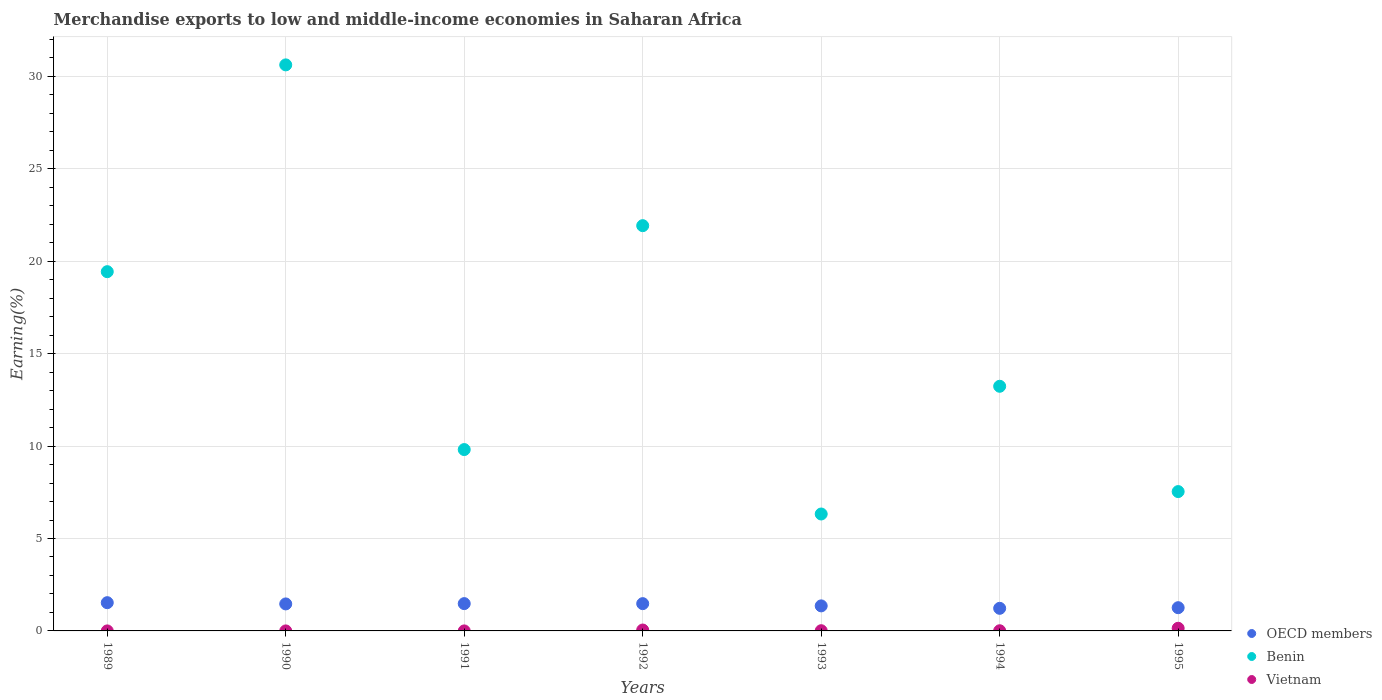How many different coloured dotlines are there?
Your answer should be compact. 3. What is the percentage of amount earned from merchandise exports in Benin in 1991?
Your response must be concise. 9.81. Across all years, what is the maximum percentage of amount earned from merchandise exports in OECD members?
Give a very brief answer. 1.53. Across all years, what is the minimum percentage of amount earned from merchandise exports in Vietnam?
Offer a very short reply. 0. What is the total percentage of amount earned from merchandise exports in OECD members in the graph?
Ensure brevity in your answer.  9.78. What is the difference between the percentage of amount earned from merchandise exports in Vietnam in 1989 and that in 1991?
Your answer should be very brief. 0. What is the difference between the percentage of amount earned from merchandise exports in Benin in 1993 and the percentage of amount earned from merchandise exports in OECD members in 1990?
Keep it short and to the point. 4.86. What is the average percentage of amount earned from merchandise exports in Benin per year?
Give a very brief answer. 15.56. In the year 1992, what is the difference between the percentage of amount earned from merchandise exports in Vietnam and percentage of amount earned from merchandise exports in OECD members?
Your response must be concise. -1.43. In how many years, is the percentage of amount earned from merchandise exports in Benin greater than 3 %?
Your answer should be compact. 7. What is the ratio of the percentage of amount earned from merchandise exports in Benin in 1991 to that in 1995?
Make the answer very short. 1.3. What is the difference between the highest and the second highest percentage of amount earned from merchandise exports in OECD members?
Provide a succinct answer. 0.05. What is the difference between the highest and the lowest percentage of amount earned from merchandise exports in Vietnam?
Make the answer very short. 0.14. Does the percentage of amount earned from merchandise exports in OECD members monotonically increase over the years?
Keep it short and to the point. No. Is the percentage of amount earned from merchandise exports in Benin strictly greater than the percentage of amount earned from merchandise exports in OECD members over the years?
Provide a succinct answer. Yes. Is the percentage of amount earned from merchandise exports in OECD members strictly less than the percentage of amount earned from merchandise exports in Vietnam over the years?
Offer a very short reply. No. How many years are there in the graph?
Provide a short and direct response. 7. What is the difference between two consecutive major ticks on the Y-axis?
Make the answer very short. 5. Where does the legend appear in the graph?
Offer a terse response. Bottom right. How many legend labels are there?
Ensure brevity in your answer.  3. What is the title of the graph?
Give a very brief answer. Merchandise exports to low and middle-income economies in Saharan Africa. What is the label or title of the X-axis?
Make the answer very short. Years. What is the label or title of the Y-axis?
Give a very brief answer. Earning(%). What is the Earning(%) in OECD members in 1989?
Make the answer very short. 1.53. What is the Earning(%) in Benin in 1989?
Ensure brevity in your answer.  19.44. What is the Earning(%) of Vietnam in 1989?
Ensure brevity in your answer.  0. What is the Earning(%) in OECD members in 1990?
Your answer should be very brief. 1.46. What is the Earning(%) in Benin in 1990?
Give a very brief answer. 30.62. What is the Earning(%) in Vietnam in 1990?
Offer a terse response. 0. What is the Earning(%) of OECD members in 1991?
Your response must be concise. 1.48. What is the Earning(%) in Benin in 1991?
Provide a succinct answer. 9.81. What is the Earning(%) in Vietnam in 1991?
Provide a succinct answer. 0. What is the Earning(%) of OECD members in 1992?
Offer a very short reply. 1.48. What is the Earning(%) in Benin in 1992?
Give a very brief answer. 21.92. What is the Earning(%) in Vietnam in 1992?
Your answer should be compact. 0.05. What is the Earning(%) in OECD members in 1993?
Provide a succinct answer. 1.35. What is the Earning(%) of Benin in 1993?
Offer a terse response. 6.33. What is the Earning(%) in Vietnam in 1993?
Provide a succinct answer. 0.01. What is the Earning(%) in OECD members in 1994?
Your answer should be compact. 1.22. What is the Earning(%) of Benin in 1994?
Provide a short and direct response. 13.24. What is the Earning(%) of Vietnam in 1994?
Provide a short and direct response. 0.01. What is the Earning(%) of OECD members in 1995?
Give a very brief answer. 1.26. What is the Earning(%) in Benin in 1995?
Your response must be concise. 7.54. What is the Earning(%) of Vietnam in 1995?
Ensure brevity in your answer.  0.14. Across all years, what is the maximum Earning(%) in OECD members?
Provide a short and direct response. 1.53. Across all years, what is the maximum Earning(%) of Benin?
Provide a short and direct response. 30.62. Across all years, what is the maximum Earning(%) in Vietnam?
Offer a terse response. 0.14. Across all years, what is the minimum Earning(%) of OECD members?
Ensure brevity in your answer.  1.22. Across all years, what is the minimum Earning(%) of Benin?
Your answer should be very brief. 6.33. Across all years, what is the minimum Earning(%) in Vietnam?
Ensure brevity in your answer.  0. What is the total Earning(%) of OECD members in the graph?
Provide a succinct answer. 9.78. What is the total Earning(%) in Benin in the graph?
Provide a short and direct response. 108.89. What is the total Earning(%) in Vietnam in the graph?
Give a very brief answer. 0.21. What is the difference between the Earning(%) of OECD members in 1989 and that in 1990?
Ensure brevity in your answer.  0.07. What is the difference between the Earning(%) in Benin in 1989 and that in 1990?
Offer a very short reply. -11.19. What is the difference between the Earning(%) of Vietnam in 1989 and that in 1990?
Provide a short and direct response. -0. What is the difference between the Earning(%) in OECD members in 1989 and that in 1991?
Keep it short and to the point. 0.05. What is the difference between the Earning(%) of Benin in 1989 and that in 1991?
Keep it short and to the point. 9.62. What is the difference between the Earning(%) in Vietnam in 1989 and that in 1991?
Your answer should be very brief. 0. What is the difference between the Earning(%) of OECD members in 1989 and that in 1992?
Offer a terse response. 0.05. What is the difference between the Earning(%) of Benin in 1989 and that in 1992?
Provide a short and direct response. -2.49. What is the difference between the Earning(%) in Vietnam in 1989 and that in 1992?
Offer a very short reply. -0.05. What is the difference between the Earning(%) in OECD members in 1989 and that in 1993?
Make the answer very short. 0.17. What is the difference between the Earning(%) of Benin in 1989 and that in 1993?
Ensure brevity in your answer.  13.11. What is the difference between the Earning(%) in Vietnam in 1989 and that in 1993?
Provide a short and direct response. -0.01. What is the difference between the Earning(%) of OECD members in 1989 and that in 1994?
Offer a very short reply. 0.31. What is the difference between the Earning(%) in Benin in 1989 and that in 1994?
Ensure brevity in your answer.  6.2. What is the difference between the Earning(%) of Vietnam in 1989 and that in 1994?
Your answer should be compact. -0.01. What is the difference between the Earning(%) in OECD members in 1989 and that in 1995?
Offer a terse response. 0.27. What is the difference between the Earning(%) of Benin in 1989 and that in 1995?
Offer a terse response. 11.9. What is the difference between the Earning(%) of Vietnam in 1989 and that in 1995?
Ensure brevity in your answer.  -0.14. What is the difference between the Earning(%) of OECD members in 1990 and that in 1991?
Provide a short and direct response. -0.02. What is the difference between the Earning(%) in Benin in 1990 and that in 1991?
Provide a short and direct response. 20.81. What is the difference between the Earning(%) of OECD members in 1990 and that in 1992?
Provide a succinct answer. -0.01. What is the difference between the Earning(%) of Benin in 1990 and that in 1992?
Make the answer very short. 8.7. What is the difference between the Earning(%) of Vietnam in 1990 and that in 1992?
Your answer should be compact. -0.05. What is the difference between the Earning(%) of OECD members in 1990 and that in 1993?
Provide a short and direct response. 0.11. What is the difference between the Earning(%) in Benin in 1990 and that in 1993?
Your answer should be very brief. 24.3. What is the difference between the Earning(%) in Vietnam in 1990 and that in 1993?
Give a very brief answer. -0.01. What is the difference between the Earning(%) of OECD members in 1990 and that in 1994?
Your answer should be very brief. 0.24. What is the difference between the Earning(%) of Benin in 1990 and that in 1994?
Give a very brief answer. 17.39. What is the difference between the Earning(%) in Vietnam in 1990 and that in 1994?
Give a very brief answer. -0.01. What is the difference between the Earning(%) of OECD members in 1990 and that in 1995?
Ensure brevity in your answer.  0.2. What is the difference between the Earning(%) of Benin in 1990 and that in 1995?
Offer a terse response. 23.08. What is the difference between the Earning(%) in Vietnam in 1990 and that in 1995?
Keep it short and to the point. -0.14. What is the difference between the Earning(%) in OECD members in 1991 and that in 1992?
Keep it short and to the point. 0. What is the difference between the Earning(%) in Benin in 1991 and that in 1992?
Your response must be concise. -12.11. What is the difference between the Earning(%) of Vietnam in 1991 and that in 1992?
Your response must be concise. -0.05. What is the difference between the Earning(%) of OECD members in 1991 and that in 1993?
Offer a very short reply. 0.12. What is the difference between the Earning(%) of Benin in 1991 and that in 1993?
Give a very brief answer. 3.49. What is the difference between the Earning(%) of Vietnam in 1991 and that in 1993?
Offer a very short reply. -0.01. What is the difference between the Earning(%) in OECD members in 1991 and that in 1994?
Make the answer very short. 0.25. What is the difference between the Earning(%) of Benin in 1991 and that in 1994?
Give a very brief answer. -3.42. What is the difference between the Earning(%) in Vietnam in 1991 and that in 1994?
Make the answer very short. -0.01. What is the difference between the Earning(%) of OECD members in 1991 and that in 1995?
Provide a succinct answer. 0.22. What is the difference between the Earning(%) of Benin in 1991 and that in 1995?
Ensure brevity in your answer.  2.27. What is the difference between the Earning(%) of Vietnam in 1991 and that in 1995?
Ensure brevity in your answer.  -0.14. What is the difference between the Earning(%) of OECD members in 1992 and that in 1993?
Your response must be concise. 0.12. What is the difference between the Earning(%) in Benin in 1992 and that in 1993?
Give a very brief answer. 15.6. What is the difference between the Earning(%) in Vietnam in 1992 and that in 1993?
Offer a very short reply. 0.04. What is the difference between the Earning(%) in OECD members in 1992 and that in 1994?
Your response must be concise. 0.25. What is the difference between the Earning(%) of Benin in 1992 and that in 1994?
Make the answer very short. 8.69. What is the difference between the Earning(%) of Vietnam in 1992 and that in 1994?
Your answer should be compact. 0.04. What is the difference between the Earning(%) of OECD members in 1992 and that in 1995?
Offer a very short reply. 0.22. What is the difference between the Earning(%) of Benin in 1992 and that in 1995?
Ensure brevity in your answer.  14.39. What is the difference between the Earning(%) of Vietnam in 1992 and that in 1995?
Provide a short and direct response. -0.09. What is the difference between the Earning(%) in OECD members in 1993 and that in 1994?
Your answer should be compact. 0.13. What is the difference between the Earning(%) in Benin in 1993 and that in 1994?
Give a very brief answer. -6.91. What is the difference between the Earning(%) in Vietnam in 1993 and that in 1994?
Give a very brief answer. 0. What is the difference between the Earning(%) in OECD members in 1993 and that in 1995?
Ensure brevity in your answer.  0.1. What is the difference between the Earning(%) of Benin in 1993 and that in 1995?
Your response must be concise. -1.21. What is the difference between the Earning(%) in Vietnam in 1993 and that in 1995?
Give a very brief answer. -0.13. What is the difference between the Earning(%) in OECD members in 1994 and that in 1995?
Keep it short and to the point. -0.03. What is the difference between the Earning(%) of Benin in 1994 and that in 1995?
Your answer should be very brief. 5.7. What is the difference between the Earning(%) of Vietnam in 1994 and that in 1995?
Your answer should be very brief. -0.13. What is the difference between the Earning(%) in OECD members in 1989 and the Earning(%) in Benin in 1990?
Offer a very short reply. -29.09. What is the difference between the Earning(%) of OECD members in 1989 and the Earning(%) of Vietnam in 1990?
Your answer should be compact. 1.53. What is the difference between the Earning(%) in Benin in 1989 and the Earning(%) in Vietnam in 1990?
Make the answer very short. 19.43. What is the difference between the Earning(%) of OECD members in 1989 and the Earning(%) of Benin in 1991?
Provide a succinct answer. -8.28. What is the difference between the Earning(%) of OECD members in 1989 and the Earning(%) of Vietnam in 1991?
Ensure brevity in your answer.  1.53. What is the difference between the Earning(%) in Benin in 1989 and the Earning(%) in Vietnam in 1991?
Your answer should be compact. 19.43. What is the difference between the Earning(%) in OECD members in 1989 and the Earning(%) in Benin in 1992?
Provide a succinct answer. -20.4. What is the difference between the Earning(%) of OECD members in 1989 and the Earning(%) of Vietnam in 1992?
Keep it short and to the point. 1.48. What is the difference between the Earning(%) in Benin in 1989 and the Earning(%) in Vietnam in 1992?
Your response must be concise. 19.39. What is the difference between the Earning(%) of OECD members in 1989 and the Earning(%) of Benin in 1993?
Offer a terse response. -4.8. What is the difference between the Earning(%) in OECD members in 1989 and the Earning(%) in Vietnam in 1993?
Your response must be concise. 1.52. What is the difference between the Earning(%) in Benin in 1989 and the Earning(%) in Vietnam in 1993?
Give a very brief answer. 19.42. What is the difference between the Earning(%) of OECD members in 1989 and the Earning(%) of Benin in 1994?
Provide a short and direct response. -11.71. What is the difference between the Earning(%) in OECD members in 1989 and the Earning(%) in Vietnam in 1994?
Provide a succinct answer. 1.52. What is the difference between the Earning(%) of Benin in 1989 and the Earning(%) of Vietnam in 1994?
Your response must be concise. 19.43. What is the difference between the Earning(%) of OECD members in 1989 and the Earning(%) of Benin in 1995?
Keep it short and to the point. -6.01. What is the difference between the Earning(%) of OECD members in 1989 and the Earning(%) of Vietnam in 1995?
Provide a short and direct response. 1.38. What is the difference between the Earning(%) of Benin in 1989 and the Earning(%) of Vietnam in 1995?
Make the answer very short. 19.29. What is the difference between the Earning(%) of OECD members in 1990 and the Earning(%) of Benin in 1991?
Your answer should be very brief. -8.35. What is the difference between the Earning(%) of OECD members in 1990 and the Earning(%) of Vietnam in 1991?
Make the answer very short. 1.46. What is the difference between the Earning(%) in Benin in 1990 and the Earning(%) in Vietnam in 1991?
Your answer should be compact. 30.62. What is the difference between the Earning(%) in OECD members in 1990 and the Earning(%) in Benin in 1992?
Make the answer very short. -20.46. What is the difference between the Earning(%) of OECD members in 1990 and the Earning(%) of Vietnam in 1992?
Provide a short and direct response. 1.41. What is the difference between the Earning(%) of Benin in 1990 and the Earning(%) of Vietnam in 1992?
Provide a succinct answer. 30.57. What is the difference between the Earning(%) in OECD members in 1990 and the Earning(%) in Benin in 1993?
Give a very brief answer. -4.86. What is the difference between the Earning(%) of OECD members in 1990 and the Earning(%) of Vietnam in 1993?
Provide a succinct answer. 1.45. What is the difference between the Earning(%) in Benin in 1990 and the Earning(%) in Vietnam in 1993?
Offer a terse response. 30.61. What is the difference between the Earning(%) in OECD members in 1990 and the Earning(%) in Benin in 1994?
Give a very brief answer. -11.77. What is the difference between the Earning(%) in OECD members in 1990 and the Earning(%) in Vietnam in 1994?
Keep it short and to the point. 1.45. What is the difference between the Earning(%) in Benin in 1990 and the Earning(%) in Vietnam in 1994?
Give a very brief answer. 30.61. What is the difference between the Earning(%) of OECD members in 1990 and the Earning(%) of Benin in 1995?
Your answer should be compact. -6.08. What is the difference between the Earning(%) of OECD members in 1990 and the Earning(%) of Vietnam in 1995?
Make the answer very short. 1.32. What is the difference between the Earning(%) in Benin in 1990 and the Earning(%) in Vietnam in 1995?
Make the answer very short. 30.48. What is the difference between the Earning(%) in OECD members in 1991 and the Earning(%) in Benin in 1992?
Make the answer very short. -20.45. What is the difference between the Earning(%) in OECD members in 1991 and the Earning(%) in Vietnam in 1992?
Your answer should be very brief. 1.43. What is the difference between the Earning(%) of Benin in 1991 and the Earning(%) of Vietnam in 1992?
Make the answer very short. 9.76. What is the difference between the Earning(%) of OECD members in 1991 and the Earning(%) of Benin in 1993?
Give a very brief answer. -4.85. What is the difference between the Earning(%) of OECD members in 1991 and the Earning(%) of Vietnam in 1993?
Make the answer very short. 1.47. What is the difference between the Earning(%) of Benin in 1991 and the Earning(%) of Vietnam in 1993?
Your response must be concise. 9.8. What is the difference between the Earning(%) of OECD members in 1991 and the Earning(%) of Benin in 1994?
Give a very brief answer. -11.76. What is the difference between the Earning(%) of OECD members in 1991 and the Earning(%) of Vietnam in 1994?
Your answer should be compact. 1.47. What is the difference between the Earning(%) of Benin in 1991 and the Earning(%) of Vietnam in 1994?
Your answer should be compact. 9.8. What is the difference between the Earning(%) of OECD members in 1991 and the Earning(%) of Benin in 1995?
Your answer should be compact. -6.06. What is the difference between the Earning(%) of OECD members in 1991 and the Earning(%) of Vietnam in 1995?
Make the answer very short. 1.33. What is the difference between the Earning(%) in Benin in 1991 and the Earning(%) in Vietnam in 1995?
Offer a terse response. 9.67. What is the difference between the Earning(%) of OECD members in 1992 and the Earning(%) of Benin in 1993?
Keep it short and to the point. -4.85. What is the difference between the Earning(%) in OECD members in 1992 and the Earning(%) in Vietnam in 1993?
Keep it short and to the point. 1.46. What is the difference between the Earning(%) in Benin in 1992 and the Earning(%) in Vietnam in 1993?
Your response must be concise. 21.91. What is the difference between the Earning(%) of OECD members in 1992 and the Earning(%) of Benin in 1994?
Keep it short and to the point. -11.76. What is the difference between the Earning(%) of OECD members in 1992 and the Earning(%) of Vietnam in 1994?
Provide a succinct answer. 1.47. What is the difference between the Earning(%) in Benin in 1992 and the Earning(%) in Vietnam in 1994?
Keep it short and to the point. 21.92. What is the difference between the Earning(%) of OECD members in 1992 and the Earning(%) of Benin in 1995?
Your answer should be compact. -6.06. What is the difference between the Earning(%) of OECD members in 1992 and the Earning(%) of Vietnam in 1995?
Give a very brief answer. 1.33. What is the difference between the Earning(%) in Benin in 1992 and the Earning(%) in Vietnam in 1995?
Give a very brief answer. 21.78. What is the difference between the Earning(%) of OECD members in 1993 and the Earning(%) of Benin in 1994?
Give a very brief answer. -11.88. What is the difference between the Earning(%) in OECD members in 1993 and the Earning(%) in Vietnam in 1994?
Give a very brief answer. 1.35. What is the difference between the Earning(%) of Benin in 1993 and the Earning(%) of Vietnam in 1994?
Offer a terse response. 6.32. What is the difference between the Earning(%) of OECD members in 1993 and the Earning(%) of Benin in 1995?
Your response must be concise. -6.18. What is the difference between the Earning(%) of OECD members in 1993 and the Earning(%) of Vietnam in 1995?
Your answer should be compact. 1.21. What is the difference between the Earning(%) in Benin in 1993 and the Earning(%) in Vietnam in 1995?
Provide a short and direct response. 6.18. What is the difference between the Earning(%) in OECD members in 1994 and the Earning(%) in Benin in 1995?
Offer a very short reply. -6.32. What is the difference between the Earning(%) in OECD members in 1994 and the Earning(%) in Vietnam in 1995?
Your answer should be very brief. 1.08. What is the difference between the Earning(%) of Benin in 1994 and the Earning(%) of Vietnam in 1995?
Offer a very short reply. 13.09. What is the average Earning(%) in OECD members per year?
Ensure brevity in your answer.  1.4. What is the average Earning(%) in Benin per year?
Your response must be concise. 15.56. What is the average Earning(%) of Vietnam per year?
Provide a short and direct response. 0.03. In the year 1989, what is the difference between the Earning(%) in OECD members and Earning(%) in Benin?
Give a very brief answer. -17.91. In the year 1989, what is the difference between the Earning(%) of OECD members and Earning(%) of Vietnam?
Offer a very short reply. 1.53. In the year 1989, what is the difference between the Earning(%) in Benin and Earning(%) in Vietnam?
Offer a very short reply. 19.43. In the year 1990, what is the difference between the Earning(%) of OECD members and Earning(%) of Benin?
Offer a very short reply. -29.16. In the year 1990, what is the difference between the Earning(%) of OECD members and Earning(%) of Vietnam?
Keep it short and to the point. 1.46. In the year 1990, what is the difference between the Earning(%) in Benin and Earning(%) in Vietnam?
Provide a short and direct response. 30.62. In the year 1991, what is the difference between the Earning(%) in OECD members and Earning(%) in Benin?
Your response must be concise. -8.33. In the year 1991, what is the difference between the Earning(%) in OECD members and Earning(%) in Vietnam?
Offer a terse response. 1.48. In the year 1991, what is the difference between the Earning(%) in Benin and Earning(%) in Vietnam?
Your answer should be compact. 9.81. In the year 1992, what is the difference between the Earning(%) in OECD members and Earning(%) in Benin?
Give a very brief answer. -20.45. In the year 1992, what is the difference between the Earning(%) of OECD members and Earning(%) of Vietnam?
Your answer should be very brief. 1.43. In the year 1992, what is the difference between the Earning(%) in Benin and Earning(%) in Vietnam?
Make the answer very short. 21.88. In the year 1993, what is the difference between the Earning(%) of OECD members and Earning(%) of Benin?
Your answer should be very brief. -4.97. In the year 1993, what is the difference between the Earning(%) of OECD members and Earning(%) of Vietnam?
Give a very brief answer. 1.34. In the year 1993, what is the difference between the Earning(%) of Benin and Earning(%) of Vietnam?
Keep it short and to the point. 6.31. In the year 1994, what is the difference between the Earning(%) in OECD members and Earning(%) in Benin?
Offer a very short reply. -12.01. In the year 1994, what is the difference between the Earning(%) of OECD members and Earning(%) of Vietnam?
Keep it short and to the point. 1.21. In the year 1994, what is the difference between the Earning(%) in Benin and Earning(%) in Vietnam?
Your response must be concise. 13.23. In the year 1995, what is the difference between the Earning(%) in OECD members and Earning(%) in Benin?
Provide a short and direct response. -6.28. In the year 1995, what is the difference between the Earning(%) of OECD members and Earning(%) of Vietnam?
Ensure brevity in your answer.  1.11. In the year 1995, what is the difference between the Earning(%) of Benin and Earning(%) of Vietnam?
Offer a very short reply. 7.39. What is the ratio of the Earning(%) of OECD members in 1989 to that in 1990?
Offer a terse response. 1.05. What is the ratio of the Earning(%) in Benin in 1989 to that in 1990?
Offer a very short reply. 0.63. What is the ratio of the Earning(%) of Vietnam in 1989 to that in 1990?
Provide a succinct answer. 0.72. What is the ratio of the Earning(%) of OECD members in 1989 to that in 1991?
Provide a short and direct response. 1.03. What is the ratio of the Earning(%) in Benin in 1989 to that in 1991?
Provide a succinct answer. 1.98. What is the ratio of the Earning(%) in Vietnam in 1989 to that in 1991?
Your answer should be compact. 1.77. What is the ratio of the Earning(%) of OECD members in 1989 to that in 1992?
Your response must be concise. 1.04. What is the ratio of the Earning(%) of Benin in 1989 to that in 1992?
Make the answer very short. 0.89. What is the ratio of the Earning(%) of OECD members in 1989 to that in 1993?
Give a very brief answer. 1.13. What is the ratio of the Earning(%) in Benin in 1989 to that in 1993?
Offer a terse response. 3.07. What is the ratio of the Earning(%) in Vietnam in 1989 to that in 1993?
Provide a succinct answer. 0.04. What is the ratio of the Earning(%) of OECD members in 1989 to that in 1994?
Keep it short and to the point. 1.25. What is the ratio of the Earning(%) of Benin in 1989 to that in 1994?
Offer a terse response. 1.47. What is the ratio of the Earning(%) in Vietnam in 1989 to that in 1994?
Make the answer very short. 0.05. What is the ratio of the Earning(%) of OECD members in 1989 to that in 1995?
Ensure brevity in your answer.  1.22. What is the ratio of the Earning(%) in Benin in 1989 to that in 1995?
Give a very brief answer. 2.58. What is the ratio of the Earning(%) in Vietnam in 1989 to that in 1995?
Provide a short and direct response. 0. What is the ratio of the Earning(%) of OECD members in 1990 to that in 1991?
Offer a terse response. 0.99. What is the ratio of the Earning(%) in Benin in 1990 to that in 1991?
Provide a succinct answer. 3.12. What is the ratio of the Earning(%) in Vietnam in 1990 to that in 1991?
Offer a terse response. 2.46. What is the ratio of the Earning(%) of OECD members in 1990 to that in 1992?
Offer a very short reply. 0.99. What is the ratio of the Earning(%) in Benin in 1990 to that in 1992?
Your answer should be compact. 1.4. What is the ratio of the Earning(%) in Vietnam in 1990 to that in 1992?
Provide a short and direct response. 0.01. What is the ratio of the Earning(%) of OECD members in 1990 to that in 1993?
Provide a succinct answer. 1.08. What is the ratio of the Earning(%) in Benin in 1990 to that in 1993?
Your response must be concise. 4.84. What is the ratio of the Earning(%) of Vietnam in 1990 to that in 1993?
Your answer should be compact. 0.06. What is the ratio of the Earning(%) of OECD members in 1990 to that in 1994?
Your response must be concise. 1.19. What is the ratio of the Earning(%) of Benin in 1990 to that in 1994?
Keep it short and to the point. 2.31. What is the ratio of the Earning(%) of Vietnam in 1990 to that in 1994?
Your response must be concise. 0.07. What is the ratio of the Earning(%) of OECD members in 1990 to that in 1995?
Offer a very short reply. 1.16. What is the ratio of the Earning(%) in Benin in 1990 to that in 1995?
Provide a succinct answer. 4.06. What is the ratio of the Earning(%) of Vietnam in 1990 to that in 1995?
Offer a terse response. 0. What is the ratio of the Earning(%) in OECD members in 1991 to that in 1992?
Provide a succinct answer. 1. What is the ratio of the Earning(%) of Benin in 1991 to that in 1992?
Your answer should be very brief. 0.45. What is the ratio of the Earning(%) in Vietnam in 1991 to that in 1992?
Provide a short and direct response. 0.01. What is the ratio of the Earning(%) in OECD members in 1991 to that in 1993?
Keep it short and to the point. 1.09. What is the ratio of the Earning(%) of Benin in 1991 to that in 1993?
Your response must be concise. 1.55. What is the ratio of the Earning(%) of Vietnam in 1991 to that in 1993?
Give a very brief answer. 0.02. What is the ratio of the Earning(%) in OECD members in 1991 to that in 1994?
Ensure brevity in your answer.  1.21. What is the ratio of the Earning(%) in Benin in 1991 to that in 1994?
Your answer should be very brief. 0.74. What is the ratio of the Earning(%) in Vietnam in 1991 to that in 1994?
Keep it short and to the point. 0.03. What is the ratio of the Earning(%) of OECD members in 1991 to that in 1995?
Provide a short and direct response. 1.18. What is the ratio of the Earning(%) of Benin in 1991 to that in 1995?
Offer a very short reply. 1.3. What is the ratio of the Earning(%) in Vietnam in 1991 to that in 1995?
Provide a succinct answer. 0. What is the ratio of the Earning(%) in OECD members in 1992 to that in 1993?
Offer a very short reply. 1.09. What is the ratio of the Earning(%) of Benin in 1992 to that in 1993?
Provide a succinct answer. 3.47. What is the ratio of the Earning(%) in Vietnam in 1992 to that in 1993?
Make the answer very short. 4.21. What is the ratio of the Earning(%) of OECD members in 1992 to that in 1994?
Make the answer very short. 1.21. What is the ratio of the Earning(%) of Benin in 1992 to that in 1994?
Offer a terse response. 1.66. What is the ratio of the Earning(%) in Vietnam in 1992 to that in 1994?
Ensure brevity in your answer.  5.25. What is the ratio of the Earning(%) in OECD members in 1992 to that in 1995?
Provide a short and direct response. 1.17. What is the ratio of the Earning(%) in Benin in 1992 to that in 1995?
Your response must be concise. 2.91. What is the ratio of the Earning(%) in Vietnam in 1992 to that in 1995?
Provide a succinct answer. 0.34. What is the ratio of the Earning(%) of OECD members in 1993 to that in 1994?
Your answer should be very brief. 1.11. What is the ratio of the Earning(%) in Benin in 1993 to that in 1994?
Provide a succinct answer. 0.48. What is the ratio of the Earning(%) of Vietnam in 1993 to that in 1994?
Make the answer very short. 1.25. What is the ratio of the Earning(%) of OECD members in 1993 to that in 1995?
Provide a succinct answer. 1.08. What is the ratio of the Earning(%) of Benin in 1993 to that in 1995?
Make the answer very short. 0.84. What is the ratio of the Earning(%) of Vietnam in 1993 to that in 1995?
Give a very brief answer. 0.08. What is the ratio of the Earning(%) in Benin in 1994 to that in 1995?
Make the answer very short. 1.76. What is the ratio of the Earning(%) in Vietnam in 1994 to that in 1995?
Provide a succinct answer. 0.06. What is the difference between the highest and the second highest Earning(%) of OECD members?
Make the answer very short. 0.05. What is the difference between the highest and the second highest Earning(%) of Benin?
Your answer should be compact. 8.7. What is the difference between the highest and the second highest Earning(%) in Vietnam?
Keep it short and to the point. 0.09. What is the difference between the highest and the lowest Earning(%) of OECD members?
Your answer should be very brief. 0.31. What is the difference between the highest and the lowest Earning(%) in Benin?
Offer a very short reply. 24.3. What is the difference between the highest and the lowest Earning(%) in Vietnam?
Provide a succinct answer. 0.14. 